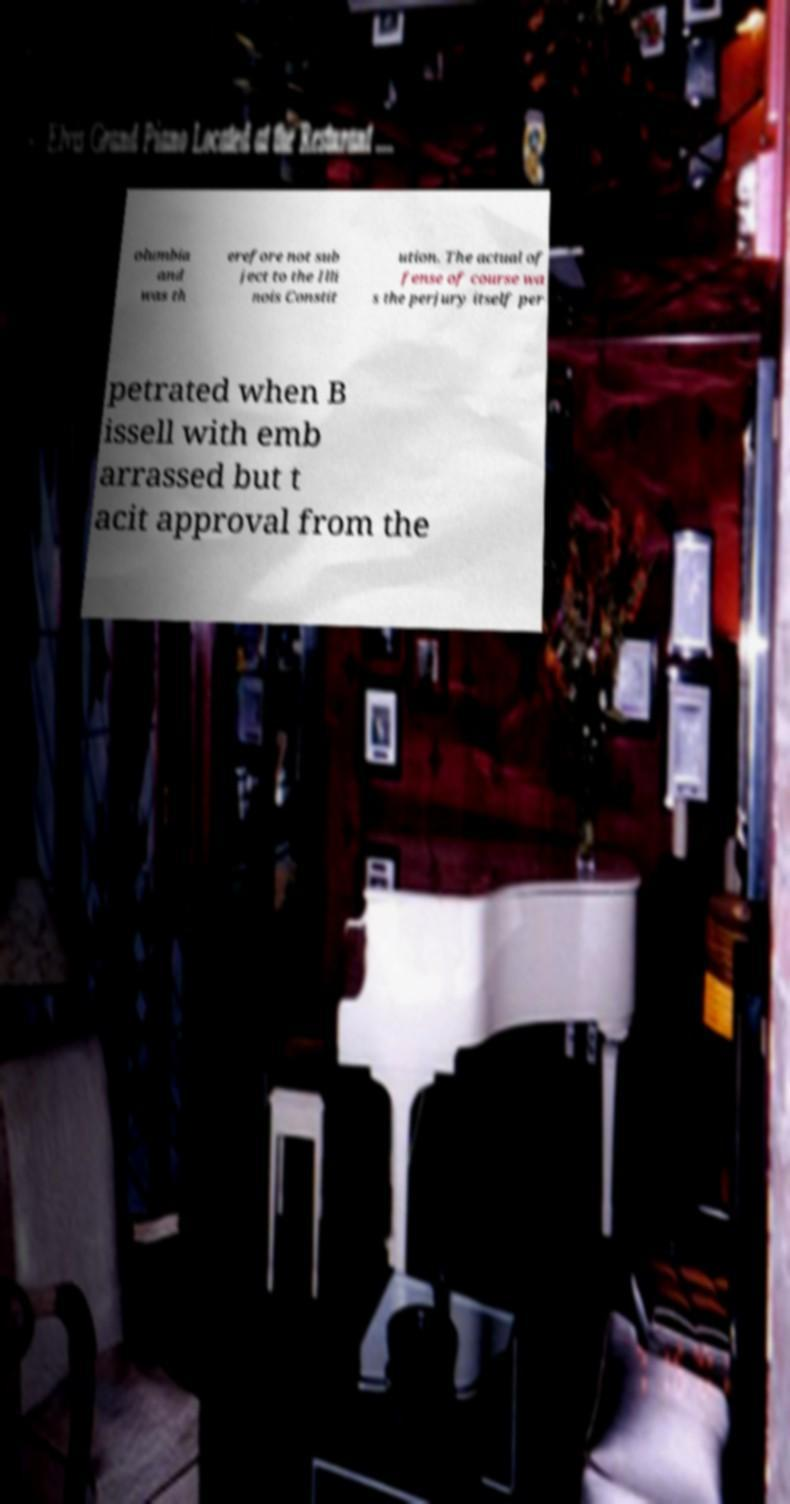What messages or text are displayed in this image? I need them in a readable, typed format. olumbia and was th erefore not sub ject to the Illi nois Constit ution. The actual of fense of course wa s the perjury itself per petrated when B issell with emb arrassed but t acit approval from the 